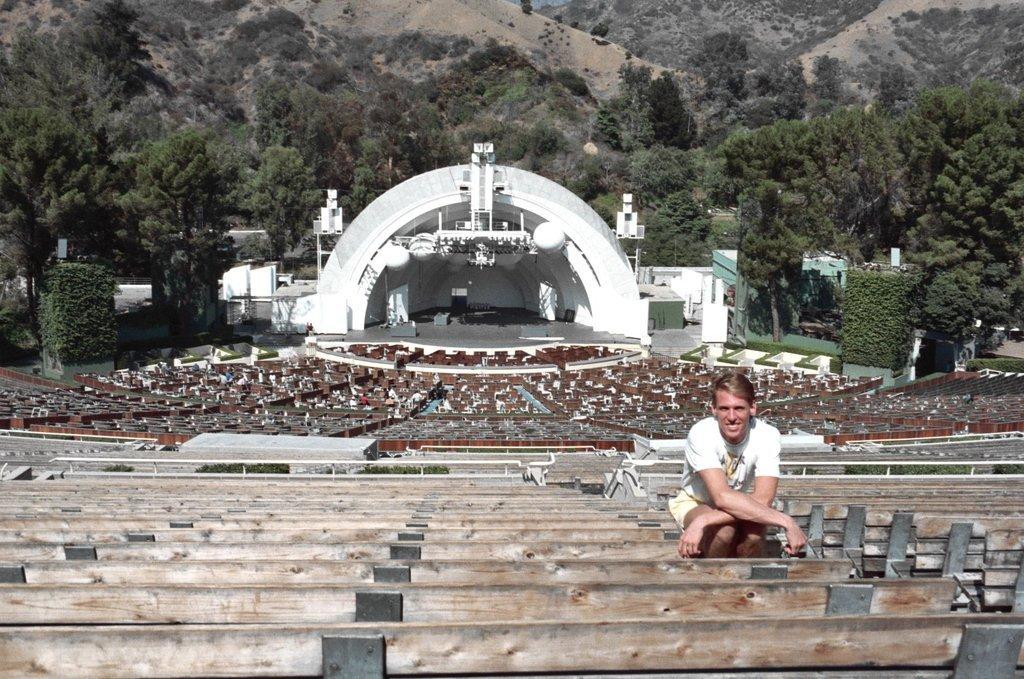In one or two sentences, can you explain what this image depicts? There is a man sitting on the bench. In the background we can see trees, benches, stage, and mountains. 